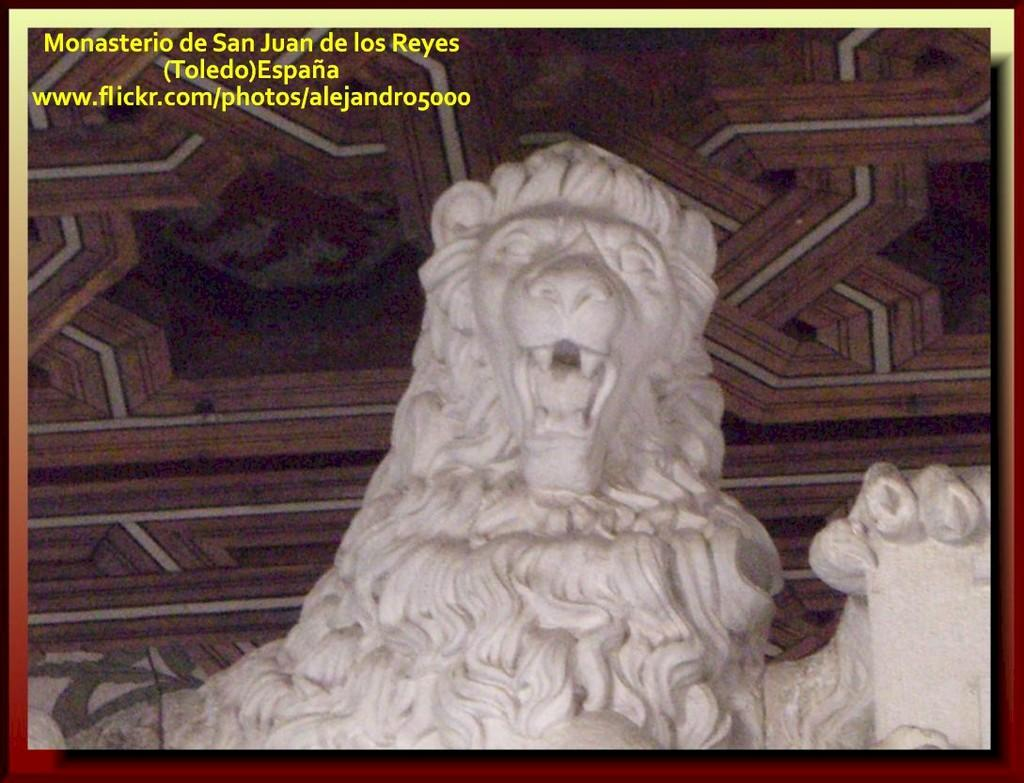What is the main subject of the image? There is a statue of a lion in the image. What color is the statue? The statue is white in color. What can be seen in the background of the image? There is a surface in the background of the image. What colors are present on the surface in the background? The surface is brown, black, and white in color. What activity is the writer engaged in while sitting on the statue? There is no writer present in the image, and the statue is not a place for someone to sit. 